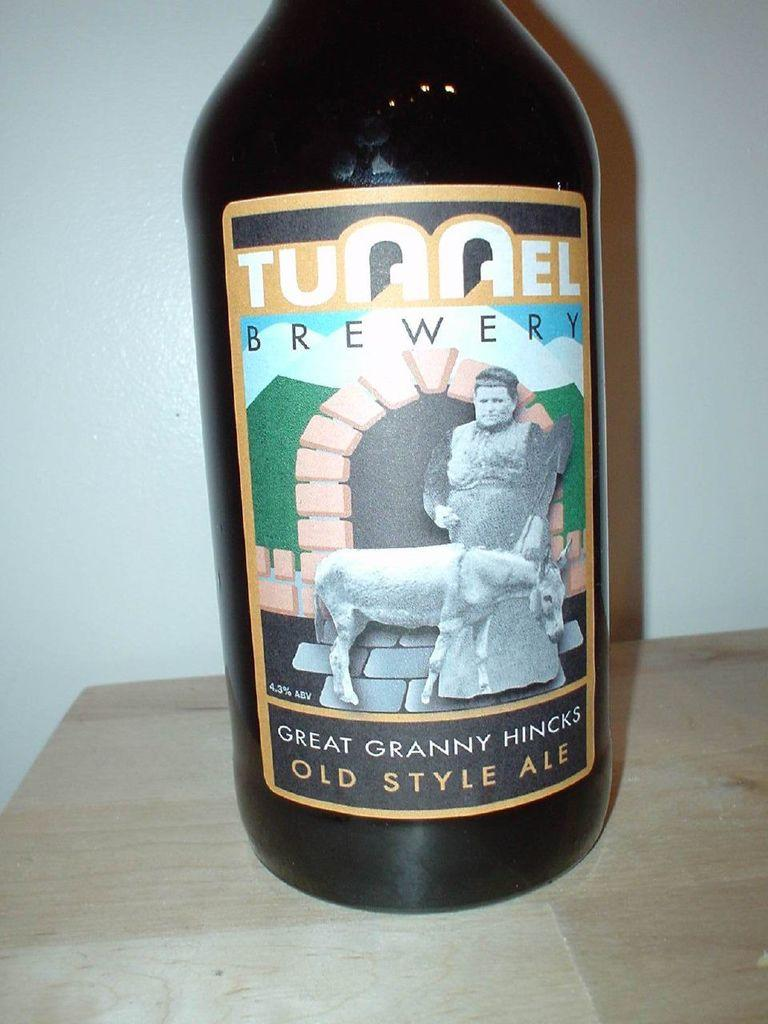<image>
Share a concise interpretation of the image provided. the word tunnel that is on a beer bottle 